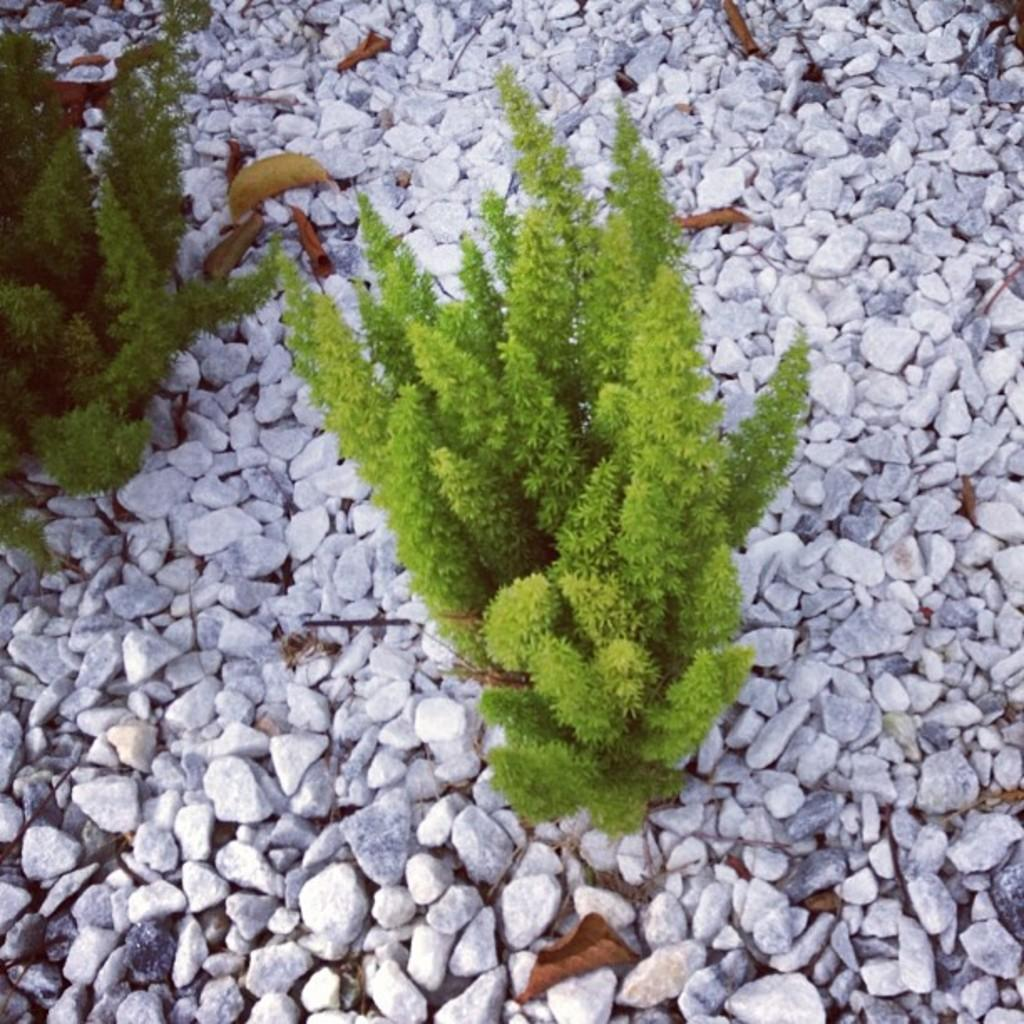What is located in the middle of the image? There are plants in the middle of the image. What else can be seen in the image besides the plants? There are stones in the image. What type of knife is being used to cut the window in the image? There is no knife or window present in the image; it only features plants and stones. 